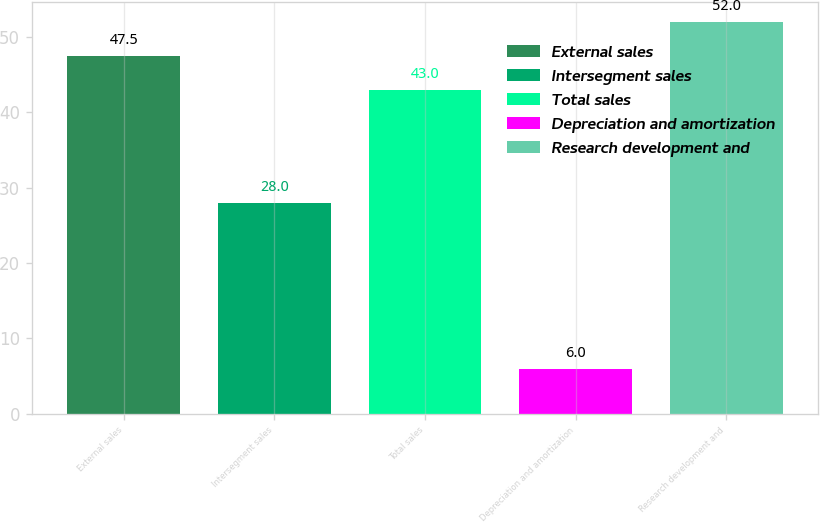<chart> <loc_0><loc_0><loc_500><loc_500><bar_chart><fcel>External sales<fcel>Intersegment sales<fcel>Total sales<fcel>Depreciation and amortization<fcel>Research development and<nl><fcel>47.5<fcel>28<fcel>43<fcel>6<fcel>52<nl></chart> 